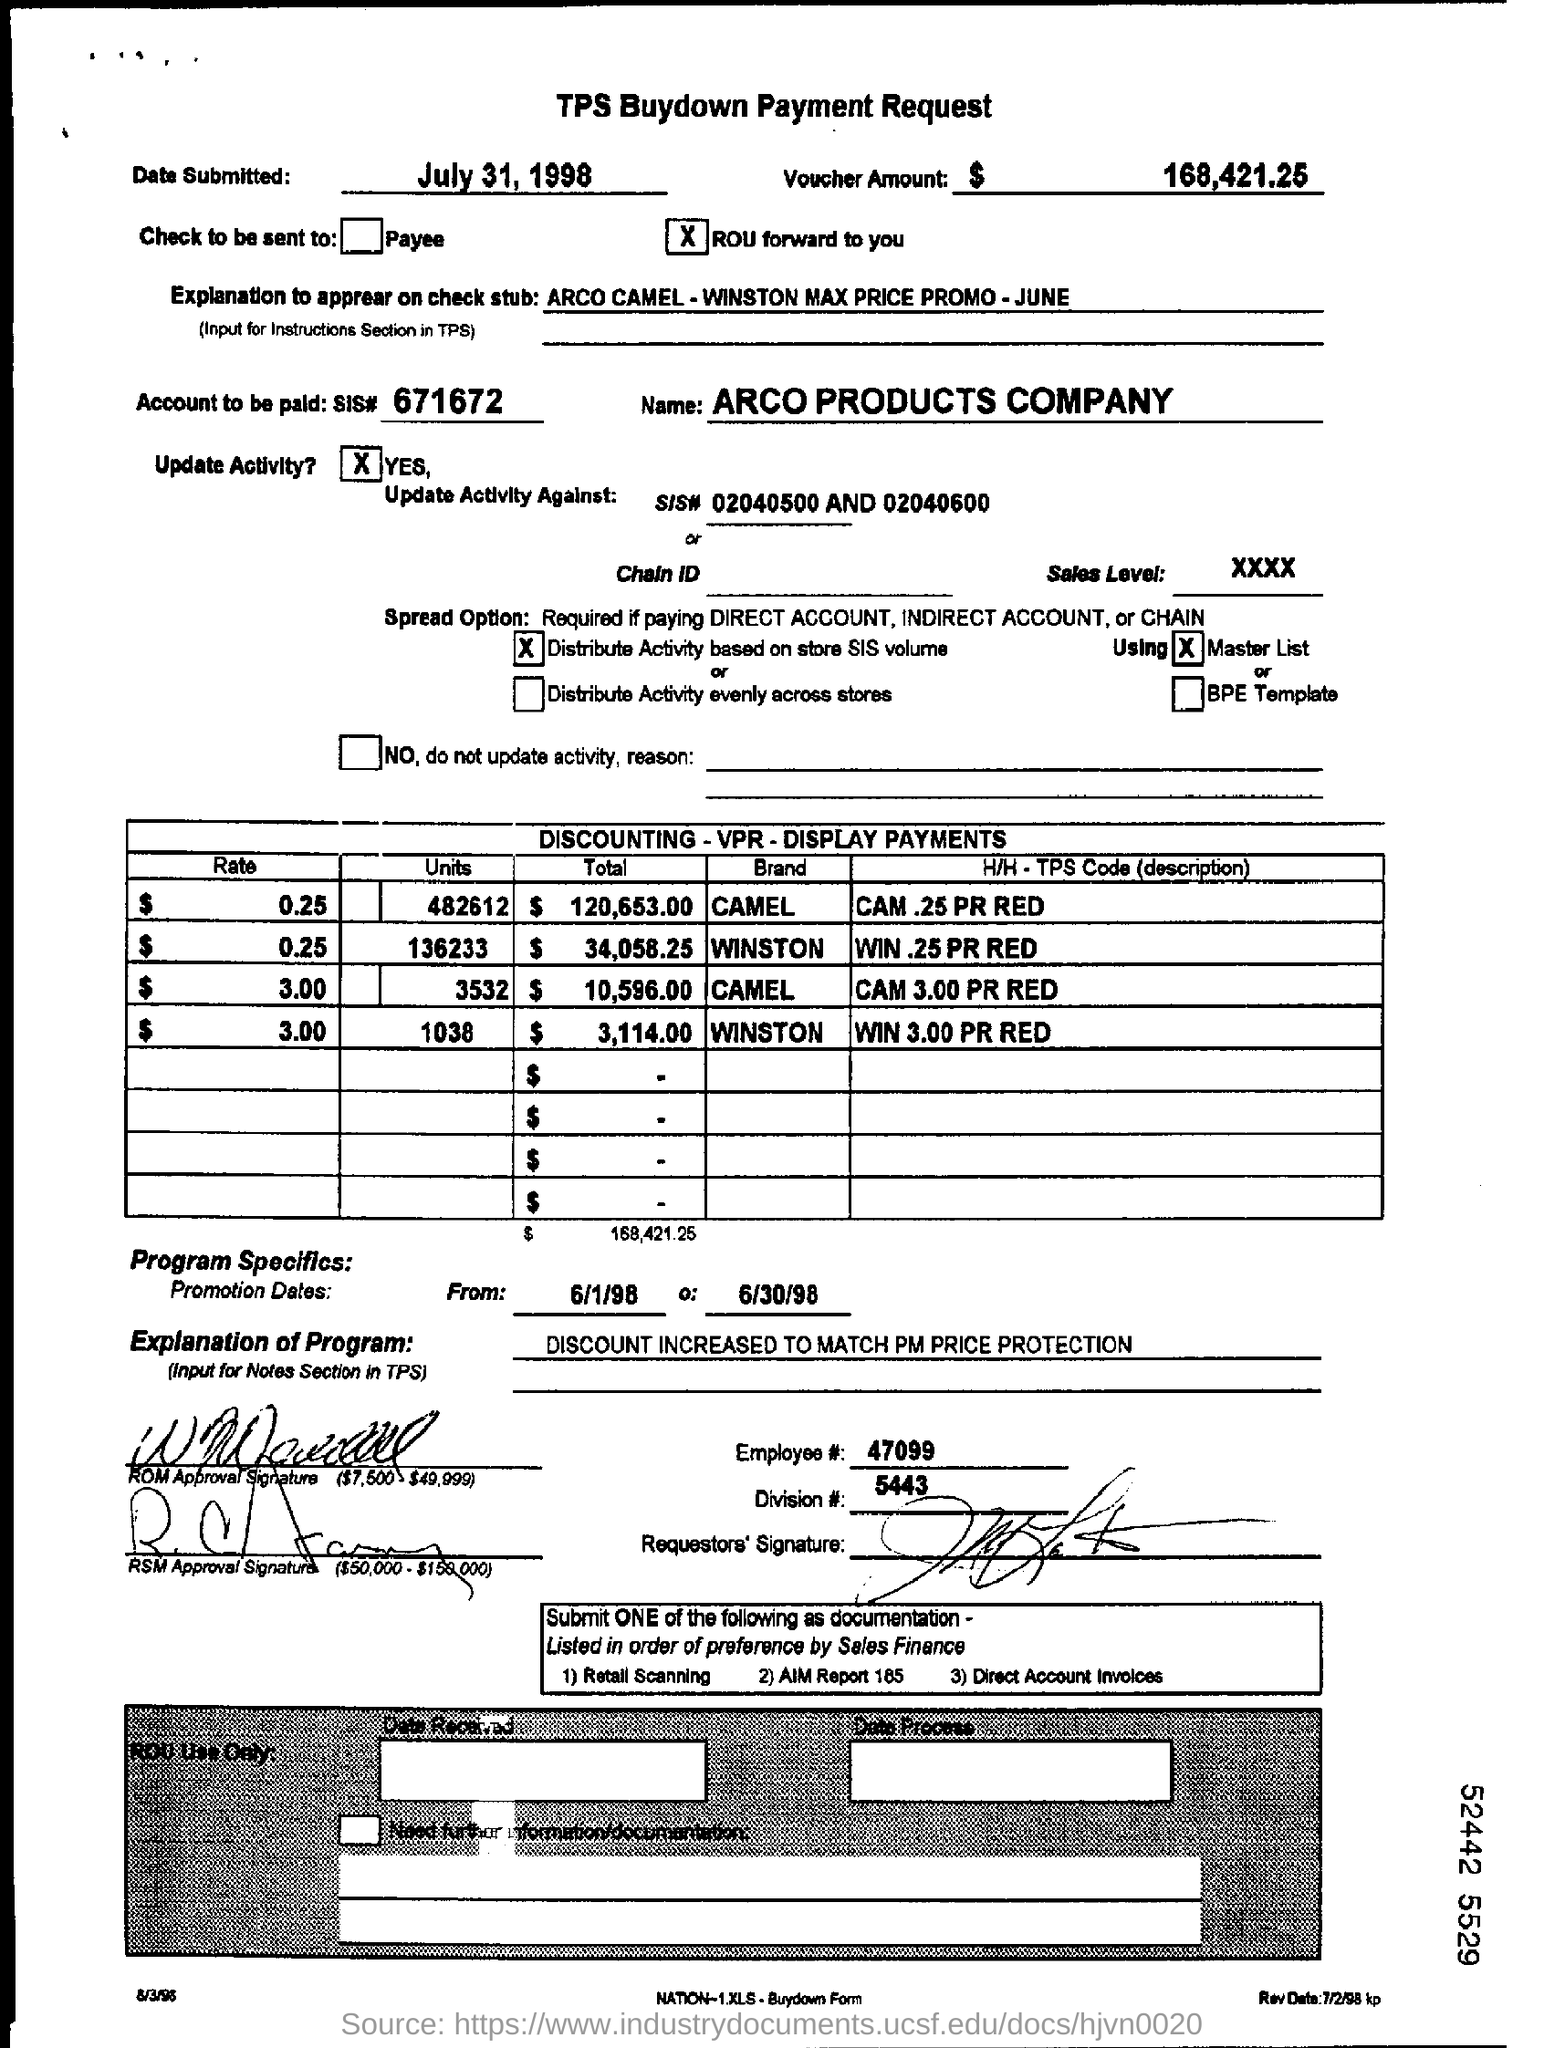List a handful of essential elements in this visual. The name of the company is Arco Products Company. The employee number is 47099. What is the account that needs to be paid? The account number is 671672... On July 31st, 1998, the TPS buydown payment request was submitted. The voucher amount is $168,421.25. 